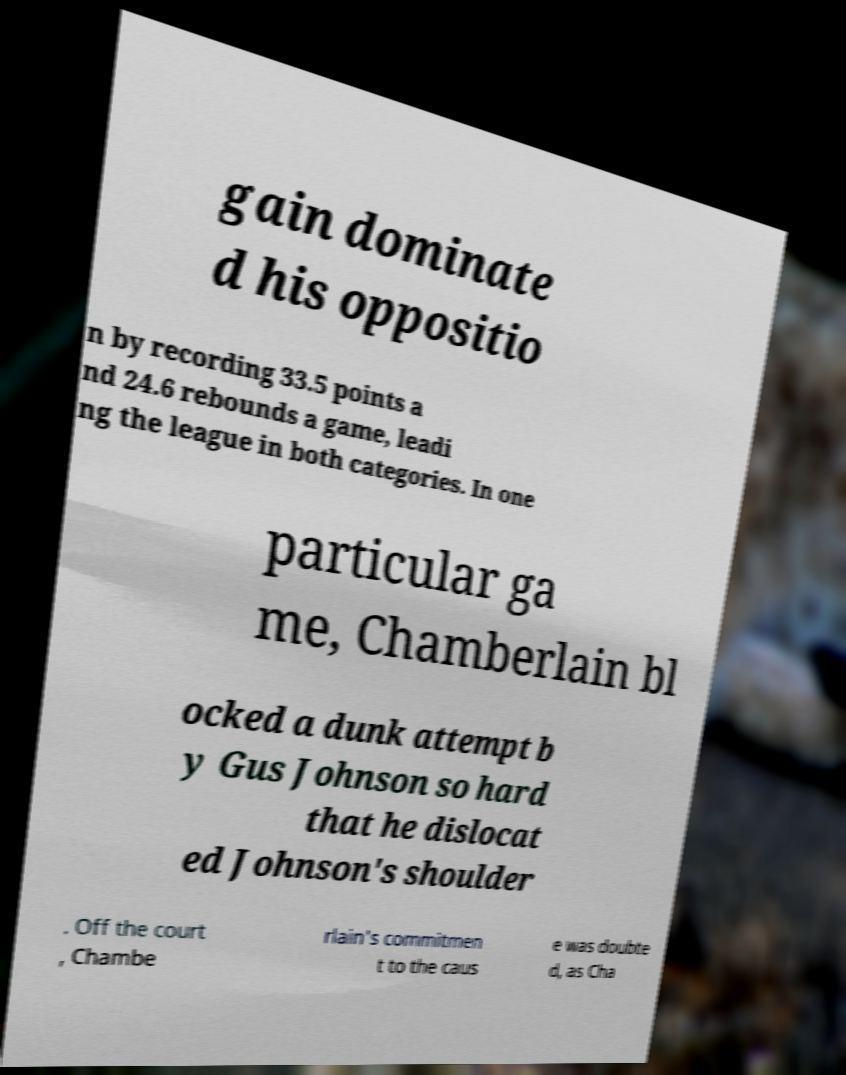What messages or text are displayed in this image? I need them in a readable, typed format. gain dominate d his oppositio n by recording 33.5 points a nd 24.6 rebounds a game, leadi ng the league in both categories. In one particular ga me, Chamberlain bl ocked a dunk attempt b y Gus Johnson so hard that he dislocat ed Johnson's shoulder . Off the court , Chambe rlain's commitmen t to the caus e was doubte d, as Cha 